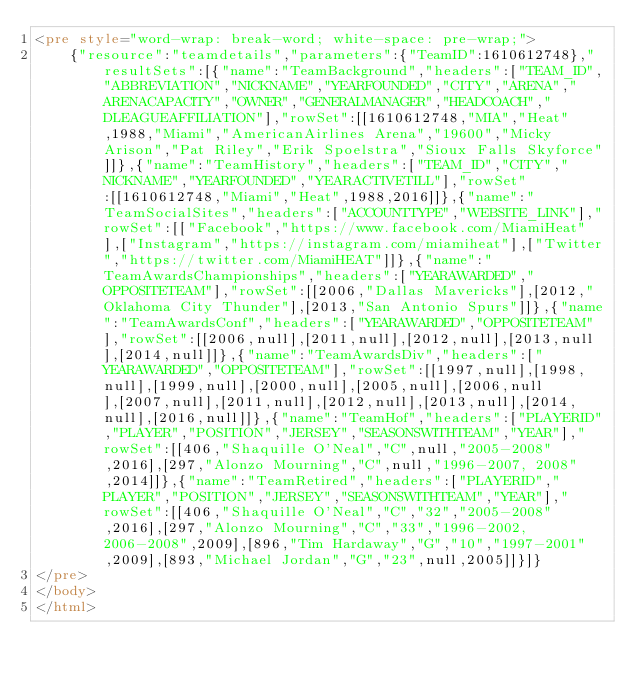Convert code to text. <code><loc_0><loc_0><loc_500><loc_500><_HTML_><pre style="word-wrap: break-word; white-space: pre-wrap;">
    {"resource":"teamdetails","parameters":{"TeamID":1610612748},"resultSets":[{"name":"TeamBackground","headers":["TEAM_ID","ABBREVIATION","NICKNAME","YEARFOUNDED","CITY","ARENA","ARENACAPACITY","OWNER","GENERALMANAGER","HEADCOACH","DLEAGUEAFFILIATION"],"rowSet":[[1610612748,"MIA","Heat",1988,"Miami","AmericanAirlines Arena","19600","Micky Arison","Pat Riley","Erik Spoelstra","Sioux Falls Skyforce"]]},{"name":"TeamHistory","headers":["TEAM_ID","CITY","NICKNAME","YEARFOUNDED","YEARACTIVETILL"],"rowSet":[[1610612748,"Miami","Heat",1988,2016]]},{"name":"TeamSocialSites","headers":["ACCOUNTTYPE","WEBSITE_LINK"],"rowSet":[["Facebook","https://www.facebook.com/MiamiHeat"],["Instagram","https://instagram.com/miamiheat"],["Twitter","https://twitter.com/MiamiHEAT"]]},{"name":"TeamAwardsChampionships","headers":["YEARAWARDED","OPPOSITETEAM"],"rowSet":[[2006,"Dallas Mavericks"],[2012,"Oklahoma City Thunder"],[2013,"San Antonio Spurs"]]},{"name":"TeamAwardsConf","headers":["YEARAWARDED","OPPOSITETEAM"],"rowSet":[[2006,null],[2011,null],[2012,null],[2013,null],[2014,null]]},{"name":"TeamAwardsDiv","headers":["YEARAWARDED","OPPOSITETEAM"],"rowSet":[[1997,null],[1998,null],[1999,null],[2000,null],[2005,null],[2006,null],[2007,null],[2011,null],[2012,null],[2013,null],[2014,null],[2016,null]]},{"name":"TeamHof","headers":["PLAYERID","PLAYER","POSITION","JERSEY","SEASONSWITHTEAM","YEAR"],"rowSet":[[406,"Shaquille O'Neal","C",null,"2005-2008",2016],[297,"Alonzo Mourning","C",null,"1996-2007, 2008",2014]]},{"name":"TeamRetired","headers":["PLAYERID","PLAYER","POSITION","JERSEY","SEASONSWITHTEAM","YEAR"],"rowSet":[[406,"Shaquille O'Neal","C","32","2005-2008",2016],[297,"Alonzo Mourning","C","33","1996-2002, 2006-2008",2009],[896,"Tim Hardaway","G","10","1997-2001",2009],[893,"Michael Jordan","G","23",null,2005]]}]}
</pre>
</body>
</html></code> 